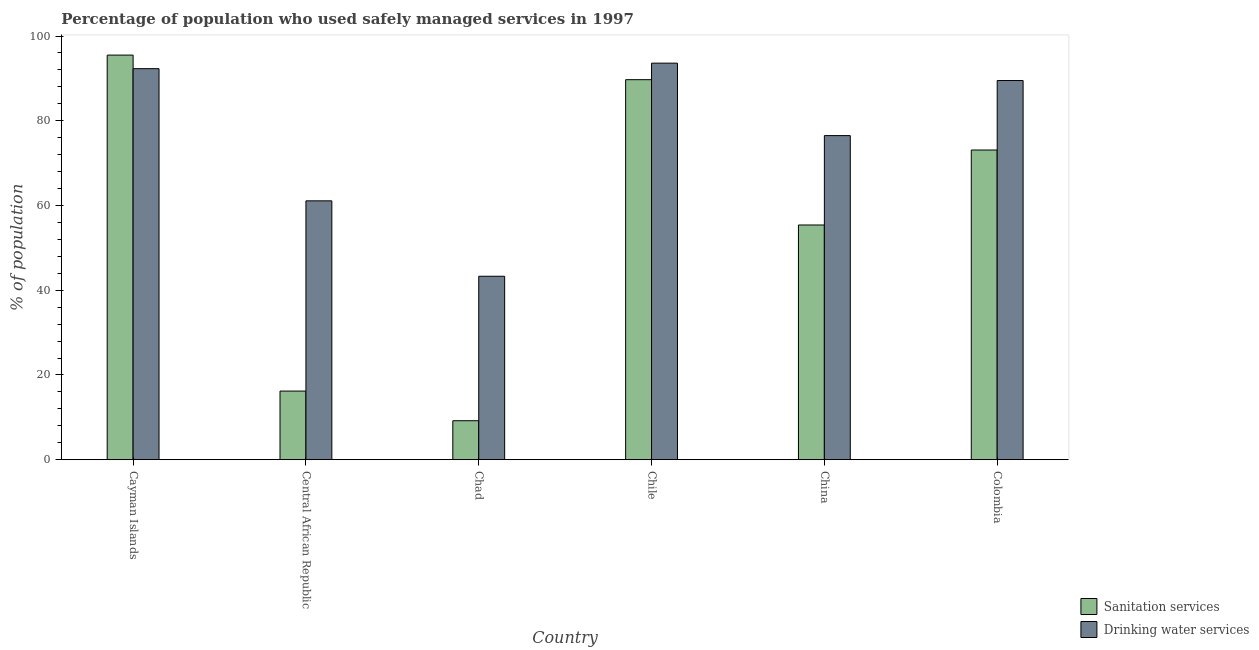Are the number of bars per tick equal to the number of legend labels?
Keep it short and to the point. Yes. Are the number of bars on each tick of the X-axis equal?
Offer a terse response. Yes. How many bars are there on the 2nd tick from the left?
Make the answer very short. 2. How many bars are there on the 1st tick from the right?
Give a very brief answer. 2. What is the label of the 2nd group of bars from the left?
Offer a terse response. Central African Republic. In how many cases, is the number of bars for a given country not equal to the number of legend labels?
Offer a very short reply. 0. What is the percentage of population who used sanitation services in Cayman Islands?
Provide a short and direct response. 95.5. Across all countries, what is the maximum percentage of population who used sanitation services?
Offer a terse response. 95.5. Across all countries, what is the minimum percentage of population who used drinking water services?
Offer a terse response. 43.3. In which country was the percentage of population who used sanitation services minimum?
Offer a terse response. Chad. What is the total percentage of population who used sanitation services in the graph?
Ensure brevity in your answer.  339.1. What is the difference between the percentage of population who used sanitation services in Central African Republic and that in Colombia?
Give a very brief answer. -56.9. What is the difference between the percentage of population who used sanitation services in Central African Republic and the percentage of population who used drinking water services in Colombia?
Give a very brief answer. -73.3. What is the average percentage of population who used drinking water services per country?
Keep it short and to the point. 76.05. What is the difference between the percentage of population who used sanitation services and percentage of population who used drinking water services in Central African Republic?
Give a very brief answer. -44.9. In how many countries, is the percentage of population who used sanitation services greater than 64 %?
Your answer should be very brief. 3. What is the ratio of the percentage of population who used sanitation services in Chile to that in China?
Your answer should be compact. 1.62. What is the difference between the highest and the second highest percentage of population who used sanitation services?
Your answer should be very brief. 5.8. What is the difference between the highest and the lowest percentage of population who used drinking water services?
Your answer should be compact. 50.3. In how many countries, is the percentage of population who used drinking water services greater than the average percentage of population who used drinking water services taken over all countries?
Keep it short and to the point. 4. What does the 2nd bar from the left in Chad represents?
Make the answer very short. Drinking water services. What does the 2nd bar from the right in China represents?
Your response must be concise. Sanitation services. How many bars are there?
Provide a succinct answer. 12. Are all the bars in the graph horizontal?
Ensure brevity in your answer.  No. What is the difference between two consecutive major ticks on the Y-axis?
Provide a short and direct response. 20. Are the values on the major ticks of Y-axis written in scientific E-notation?
Provide a short and direct response. No. Does the graph contain any zero values?
Provide a succinct answer. No. Does the graph contain grids?
Your response must be concise. No. Where does the legend appear in the graph?
Ensure brevity in your answer.  Bottom right. How many legend labels are there?
Provide a succinct answer. 2. What is the title of the graph?
Provide a succinct answer. Percentage of population who used safely managed services in 1997. Does "Resident" appear as one of the legend labels in the graph?
Provide a succinct answer. No. What is the label or title of the Y-axis?
Keep it short and to the point. % of population. What is the % of population of Sanitation services in Cayman Islands?
Offer a very short reply. 95.5. What is the % of population of Drinking water services in Cayman Islands?
Offer a very short reply. 92.3. What is the % of population of Sanitation services in Central African Republic?
Keep it short and to the point. 16.2. What is the % of population of Drinking water services in Central African Republic?
Your answer should be compact. 61.1. What is the % of population of Sanitation services in Chad?
Keep it short and to the point. 9.2. What is the % of population in Drinking water services in Chad?
Make the answer very short. 43.3. What is the % of population in Sanitation services in Chile?
Give a very brief answer. 89.7. What is the % of population of Drinking water services in Chile?
Offer a very short reply. 93.6. What is the % of population of Sanitation services in China?
Provide a succinct answer. 55.4. What is the % of population in Drinking water services in China?
Your response must be concise. 76.5. What is the % of population in Sanitation services in Colombia?
Your answer should be very brief. 73.1. What is the % of population in Drinking water services in Colombia?
Provide a short and direct response. 89.5. Across all countries, what is the maximum % of population in Sanitation services?
Make the answer very short. 95.5. Across all countries, what is the maximum % of population of Drinking water services?
Provide a succinct answer. 93.6. Across all countries, what is the minimum % of population in Drinking water services?
Offer a terse response. 43.3. What is the total % of population of Sanitation services in the graph?
Your answer should be very brief. 339.1. What is the total % of population in Drinking water services in the graph?
Offer a very short reply. 456.3. What is the difference between the % of population of Sanitation services in Cayman Islands and that in Central African Republic?
Offer a very short reply. 79.3. What is the difference between the % of population in Drinking water services in Cayman Islands and that in Central African Republic?
Offer a very short reply. 31.2. What is the difference between the % of population of Sanitation services in Cayman Islands and that in Chad?
Make the answer very short. 86.3. What is the difference between the % of population of Drinking water services in Cayman Islands and that in Chad?
Ensure brevity in your answer.  49. What is the difference between the % of population in Drinking water services in Cayman Islands and that in Chile?
Ensure brevity in your answer.  -1.3. What is the difference between the % of population of Sanitation services in Cayman Islands and that in China?
Offer a terse response. 40.1. What is the difference between the % of population in Drinking water services in Cayman Islands and that in China?
Ensure brevity in your answer.  15.8. What is the difference between the % of population in Sanitation services in Cayman Islands and that in Colombia?
Keep it short and to the point. 22.4. What is the difference between the % of population of Sanitation services in Central African Republic and that in Chad?
Provide a short and direct response. 7. What is the difference between the % of population in Drinking water services in Central African Republic and that in Chad?
Ensure brevity in your answer.  17.8. What is the difference between the % of population of Sanitation services in Central African Republic and that in Chile?
Keep it short and to the point. -73.5. What is the difference between the % of population in Drinking water services in Central African Republic and that in Chile?
Keep it short and to the point. -32.5. What is the difference between the % of population of Sanitation services in Central African Republic and that in China?
Your response must be concise. -39.2. What is the difference between the % of population in Drinking water services in Central African Republic and that in China?
Keep it short and to the point. -15.4. What is the difference between the % of population in Sanitation services in Central African Republic and that in Colombia?
Your response must be concise. -56.9. What is the difference between the % of population of Drinking water services in Central African Republic and that in Colombia?
Offer a very short reply. -28.4. What is the difference between the % of population in Sanitation services in Chad and that in Chile?
Your response must be concise. -80.5. What is the difference between the % of population in Drinking water services in Chad and that in Chile?
Your answer should be compact. -50.3. What is the difference between the % of population of Sanitation services in Chad and that in China?
Your answer should be very brief. -46.2. What is the difference between the % of population of Drinking water services in Chad and that in China?
Provide a short and direct response. -33.2. What is the difference between the % of population in Sanitation services in Chad and that in Colombia?
Keep it short and to the point. -63.9. What is the difference between the % of population in Drinking water services in Chad and that in Colombia?
Provide a succinct answer. -46.2. What is the difference between the % of population in Sanitation services in Chile and that in China?
Provide a succinct answer. 34.3. What is the difference between the % of population in Sanitation services in China and that in Colombia?
Provide a succinct answer. -17.7. What is the difference between the % of population of Sanitation services in Cayman Islands and the % of population of Drinking water services in Central African Republic?
Offer a very short reply. 34.4. What is the difference between the % of population in Sanitation services in Cayman Islands and the % of population in Drinking water services in Chad?
Offer a terse response. 52.2. What is the difference between the % of population of Sanitation services in Cayman Islands and the % of population of Drinking water services in Chile?
Your answer should be compact. 1.9. What is the difference between the % of population of Sanitation services in Central African Republic and the % of population of Drinking water services in Chad?
Provide a short and direct response. -27.1. What is the difference between the % of population of Sanitation services in Central African Republic and the % of population of Drinking water services in Chile?
Your response must be concise. -77.4. What is the difference between the % of population of Sanitation services in Central African Republic and the % of population of Drinking water services in China?
Give a very brief answer. -60.3. What is the difference between the % of population in Sanitation services in Central African Republic and the % of population in Drinking water services in Colombia?
Your response must be concise. -73.3. What is the difference between the % of population in Sanitation services in Chad and the % of population in Drinking water services in Chile?
Your response must be concise. -84.4. What is the difference between the % of population of Sanitation services in Chad and the % of population of Drinking water services in China?
Provide a succinct answer. -67.3. What is the difference between the % of population of Sanitation services in Chad and the % of population of Drinking water services in Colombia?
Ensure brevity in your answer.  -80.3. What is the difference between the % of population in Sanitation services in China and the % of population in Drinking water services in Colombia?
Provide a short and direct response. -34.1. What is the average % of population of Sanitation services per country?
Give a very brief answer. 56.52. What is the average % of population in Drinking water services per country?
Keep it short and to the point. 76.05. What is the difference between the % of population in Sanitation services and % of population in Drinking water services in Cayman Islands?
Make the answer very short. 3.2. What is the difference between the % of population of Sanitation services and % of population of Drinking water services in Central African Republic?
Provide a succinct answer. -44.9. What is the difference between the % of population in Sanitation services and % of population in Drinking water services in Chad?
Keep it short and to the point. -34.1. What is the difference between the % of population of Sanitation services and % of population of Drinking water services in Chile?
Offer a terse response. -3.9. What is the difference between the % of population in Sanitation services and % of population in Drinking water services in China?
Give a very brief answer. -21.1. What is the difference between the % of population in Sanitation services and % of population in Drinking water services in Colombia?
Your answer should be compact. -16.4. What is the ratio of the % of population of Sanitation services in Cayman Islands to that in Central African Republic?
Ensure brevity in your answer.  5.9. What is the ratio of the % of population of Drinking water services in Cayman Islands to that in Central African Republic?
Your response must be concise. 1.51. What is the ratio of the % of population of Sanitation services in Cayman Islands to that in Chad?
Keep it short and to the point. 10.38. What is the ratio of the % of population in Drinking water services in Cayman Islands to that in Chad?
Offer a very short reply. 2.13. What is the ratio of the % of population in Sanitation services in Cayman Islands to that in Chile?
Provide a short and direct response. 1.06. What is the ratio of the % of population in Drinking water services in Cayman Islands to that in Chile?
Offer a terse response. 0.99. What is the ratio of the % of population in Sanitation services in Cayman Islands to that in China?
Keep it short and to the point. 1.72. What is the ratio of the % of population of Drinking water services in Cayman Islands to that in China?
Your answer should be compact. 1.21. What is the ratio of the % of population of Sanitation services in Cayman Islands to that in Colombia?
Ensure brevity in your answer.  1.31. What is the ratio of the % of population of Drinking water services in Cayman Islands to that in Colombia?
Your response must be concise. 1.03. What is the ratio of the % of population of Sanitation services in Central African Republic to that in Chad?
Provide a succinct answer. 1.76. What is the ratio of the % of population of Drinking water services in Central African Republic to that in Chad?
Provide a short and direct response. 1.41. What is the ratio of the % of population of Sanitation services in Central African Republic to that in Chile?
Provide a succinct answer. 0.18. What is the ratio of the % of population in Drinking water services in Central African Republic to that in Chile?
Your response must be concise. 0.65. What is the ratio of the % of population of Sanitation services in Central African Republic to that in China?
Offer a very short reply. 0.29. What is the ratio of the % of population of Drinking water services in Central African Republic to that in China?
Your response must be concise. 0.8. What is the ratio of the % of population in Sanitation services in Central African Republic to that in Colombia?
Ensure brevity in your answer.  0.22. What is the ratio of the % of population of Drinking water services in Central African Republic to that in Colombia?
Your response must be concise. 0.68. What is the ratio of the % of population of Sanitation services in Chad to that in Chile?
Keep it short and to the point. 0.1. What is the ratio of the % of population in Drinking water services in Chad to that in Chile?
Ensure brevity in your answer.  0.46. What is the ratio of the % of population of Sanitation services in Chad to that in China?
Your response must be concise. 0.17. What is the ratio of the % of population of Drinking water services in Chad to that in China?
Offer a terse response. 0.57. What is the ratio of the % of population of Sanitation services in Chad to that in Colombia?
Provide a succinct answer. 0.13. What is the ratio of the % of population in Drinking water services in Chad to that in Colombia?
Your answer should be very brief. 0.48. What is the ratio of the % of population in Sanitation services in Chile to that in China?
Your response must be concise. 1.62. What is the ratio of the % of population of Drinking water services in Chile to that in China?
Your response must be concise. 1.22. What is the ratio of the % of population in Sanitation services in Chile to that in Colombia?
Provide a succinct answer. 1.23. What is the ratio of the % of population in Drinking water services in Chile to that in Colombia?
Your response must be concise. 1.05. What is the ratio of the % of population of Sanitation services in China to that in Colombia?
Ensure brevity in your answer.  0.76. What is the ratio of the % of population of Drinking water services in China to that in Colombia?
Ensure brevity in your answer.  0.85. What is the difference between the highest and the lowest % of population of Sanitation services?
Provide a succinct answer. 86.3. What is the difference between the highest and the lowest % of population in Drinking water services?
Your answer should be very brief. 50.3. 